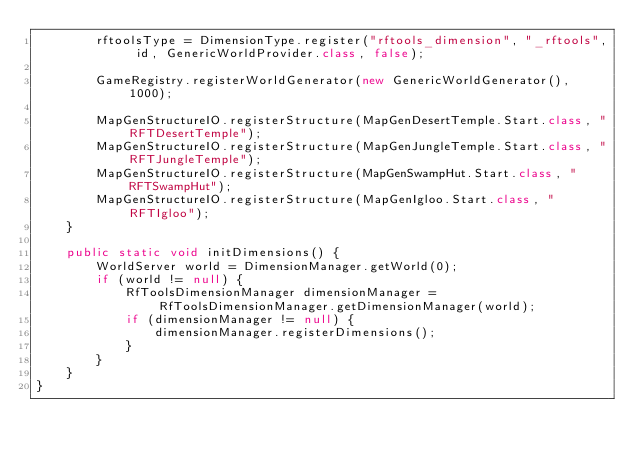<code> <loc_0><loc_0><loc_500><loc_500><_Java_>        rftoolsType = DimensionType.register("rftools_dimension", "_rftools", id, GenericWorldProvider.class, false);

        GameRegistry.registerWorldGenerator(new GenericWorldGenerator(), 1000);

        MapGenStructureIO.registerStructure(MapGenDesertTemple.Start.class, "RFTDesertTemple");
        MapGenStructureIO.registerStructure(MapGenJungleTemple.Start.class, "RFTJungleTemple");
        MapGenStructureIO.registerStructure(MapGenSwampHut.Start.class, "RFTSwampHut");
        MapGenStructureIO.registerStructure(MapGenIgloo.Start.class, "RFTIgloo");
    }

    public static void initDimensions() {
        WorldServer world = DimensionManager.getWorld(0);
        if (world != null) {
            RfToolsDimensionManager dimensionManager = RfToolsDimensionManager.getDimensionManager(world);
            if (dimensionManager != null) {
                dimensionManager.registerDimensions();
            }
        }
    }
}
</code> 